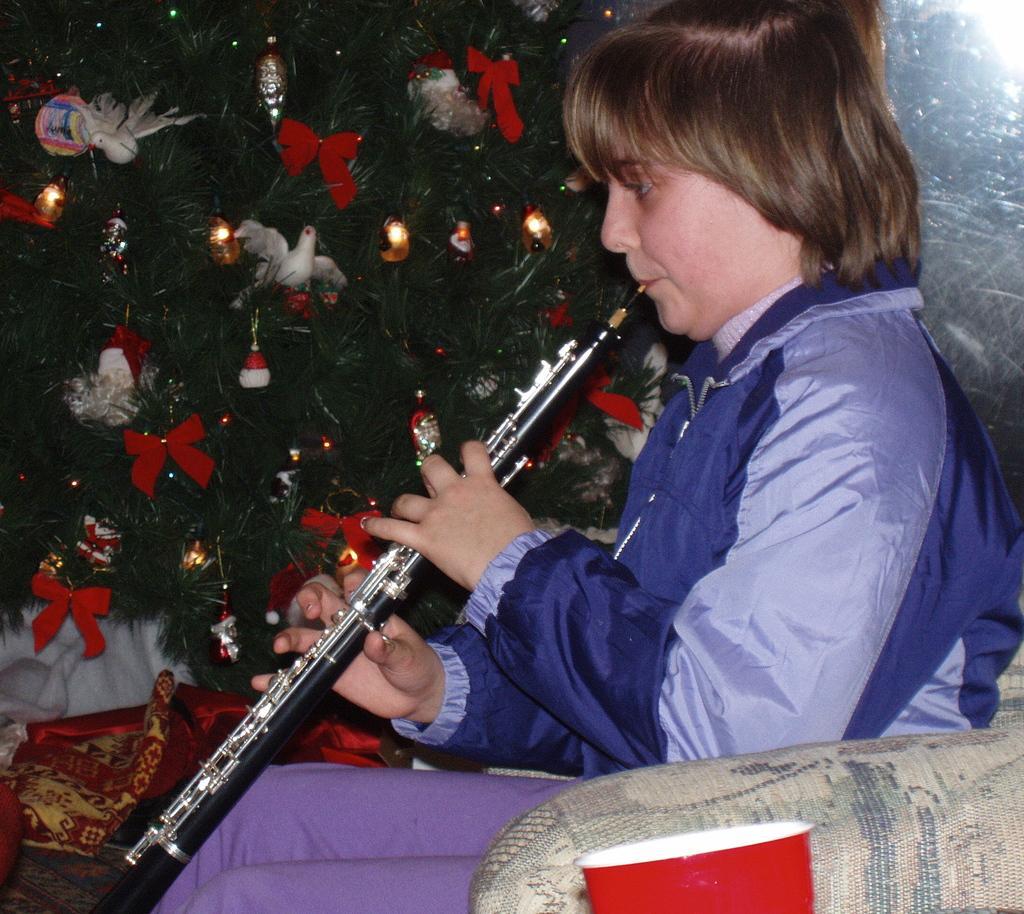Please provide a concise description of this image. In this image I can see the person sitting and holding the musical instrument and the person is wearing blue and gray color dress. In the background I can see the Christmas tree and few decorative items. 